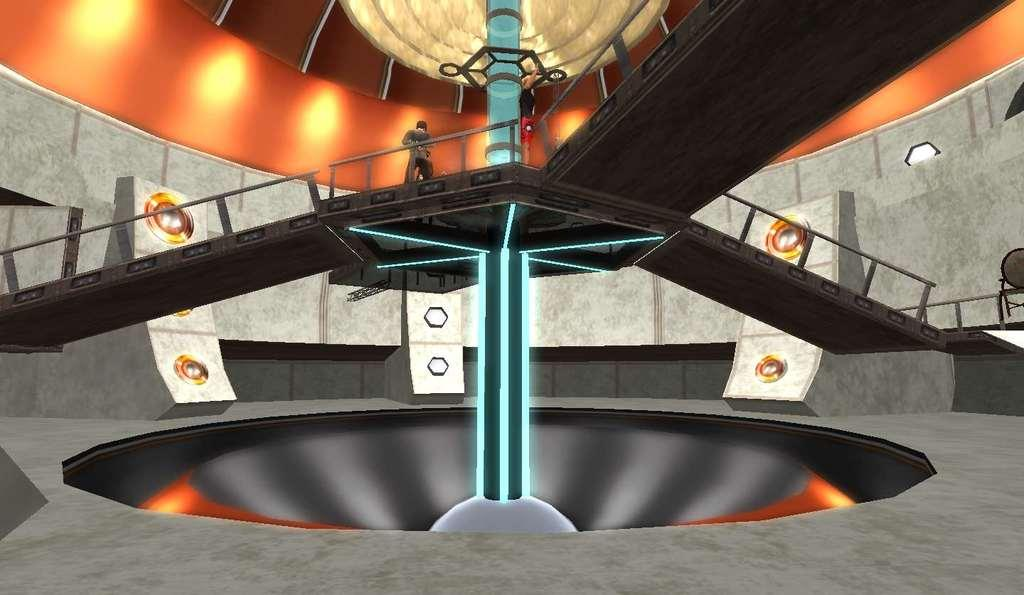What type of image is present in the picture? There is a graphical image in the picture. How many ramps can be seen in the image? There are three ramps in the image. What is visible in the background of the image? There is a wall in the background of the image. Where is the kettle located in the image? There is no kettle present in the image. What type of fireman can be seen in the image? There is no fireman present in the image. 